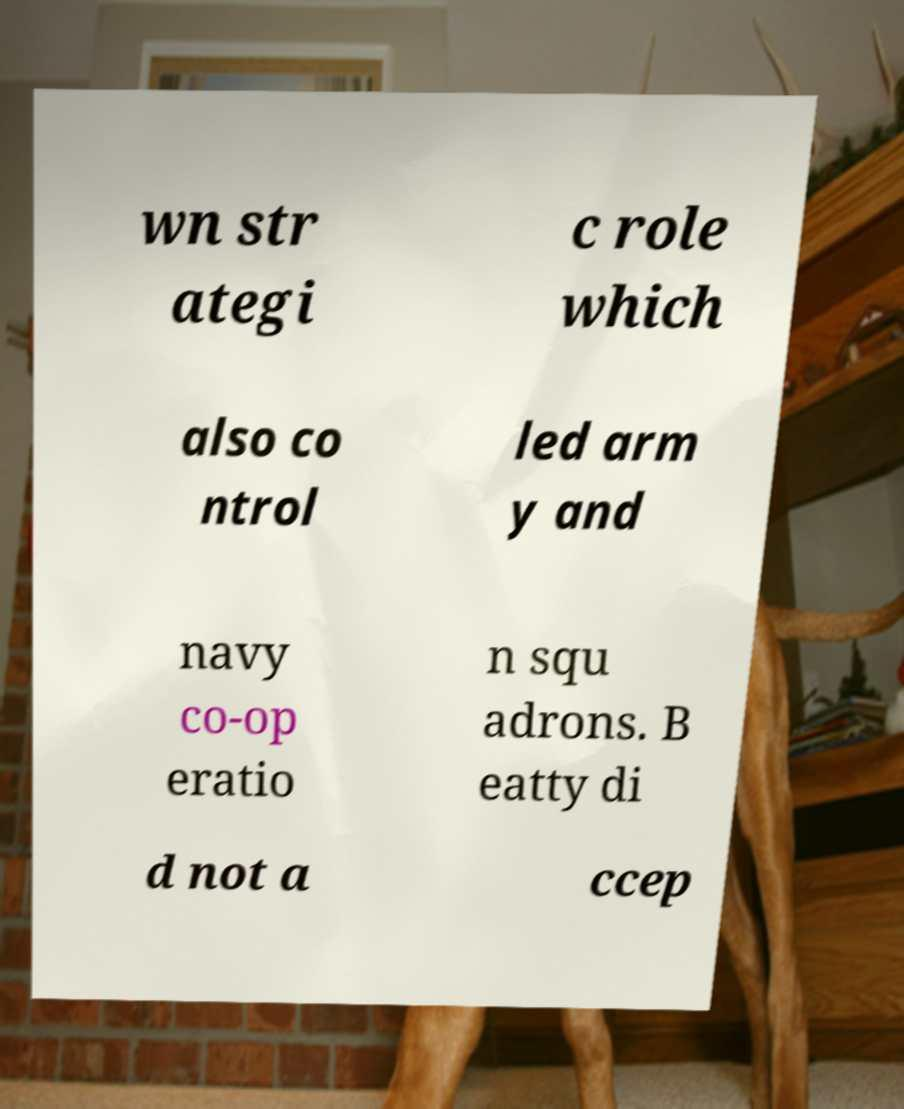There's text embedded in this image that I need extracted. Can you transcribe it verbatim? wn str ategi c role which also co ntrol led arm y and navy co-op eratio n squ adrons. B eatty di d not a ccep 